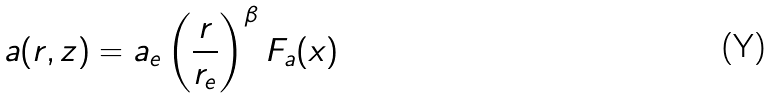<formula> <loc_0><loc_0><loc_500><loc_500>a ( r , z ) = a _ { e } \left ( \frac { r } { r _ { e } } \right ) ^ { \beta } F _ { a } ( x )</formula> 